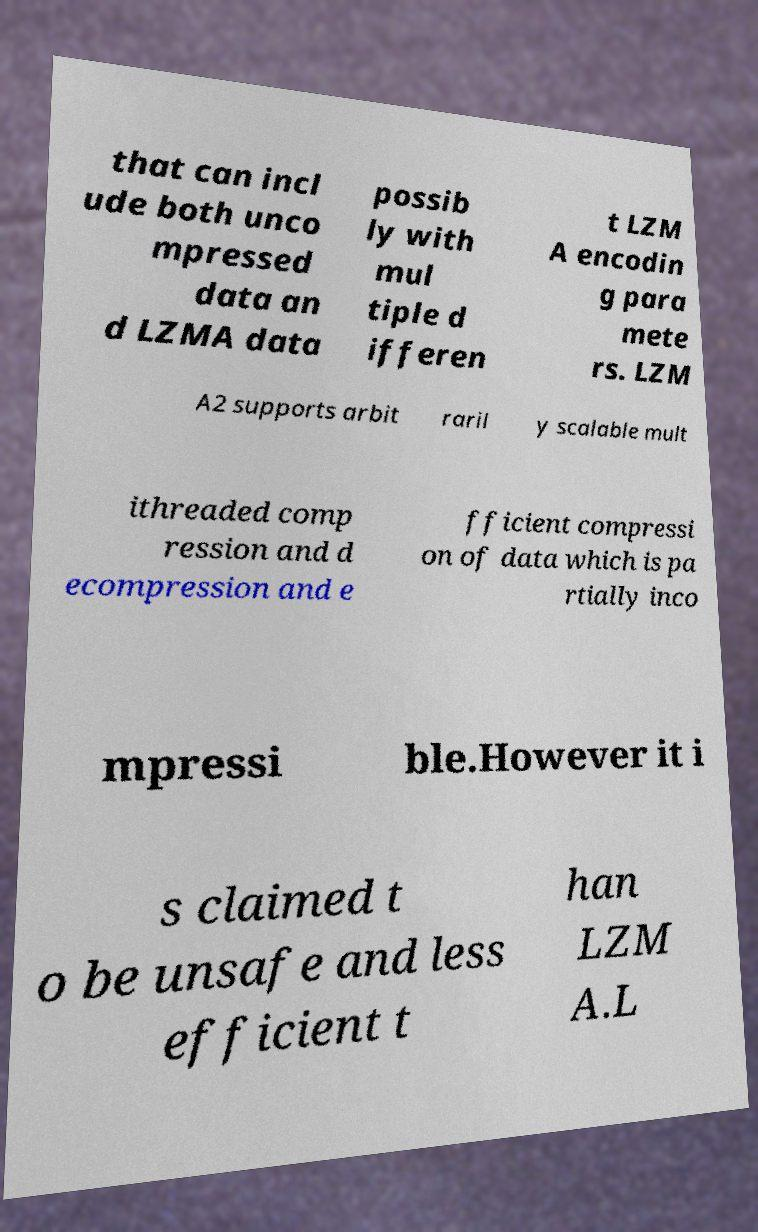Could you extract and type out the text from this image? that can incl ude both unco mpressed data an d LZMA data possib ly with mul tiple d ifferen t LZM A encodin g para mete rs. LZM A2 supports arbit raril y scalable mult ithreaded comp ression and d ecompression and e fficient compressi on of data which is pa rtially inco mpressi ble.However it i s claimed t o be unsafe and less efficient t han LZM A.L 